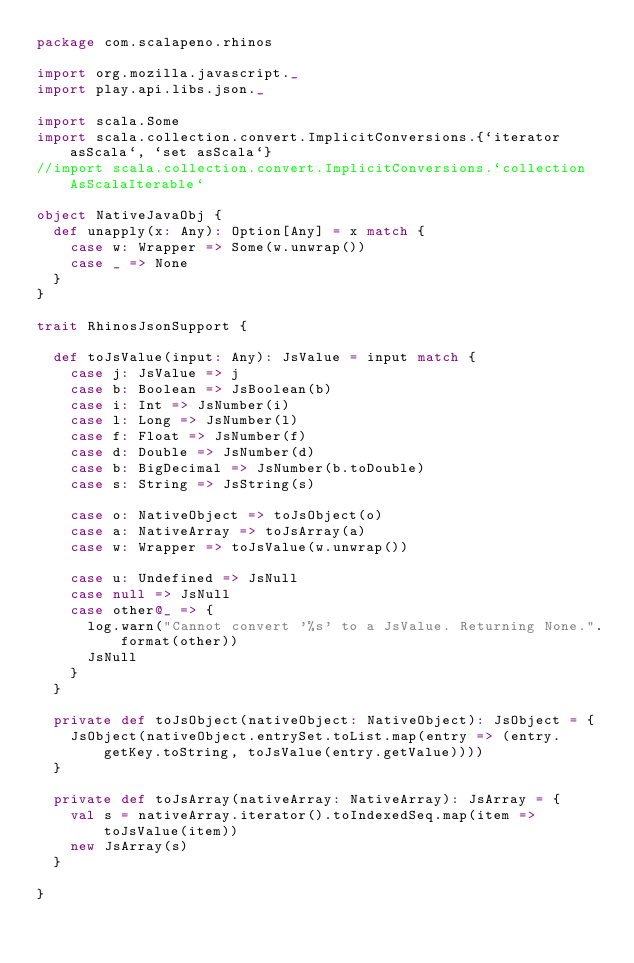Convert code to text. <code><loc_0><loc_0><loc_500><loc_500><_Scala_>package com.scalapeno.rhinos

import org.mozilla.javascript._
import play.api.libs.json._

import scala.Some
import scala.collection.convert.ImplicitConversions.{`iterator asScala`, `set asScala`}
//import scala.collection.convert.ImplicitConversions.`collection AsScalaIterable`

object NativeJavaObj {
  def unapply(x: Any): Option[Any] = x match {
    case w: Wrapper => Some(w.unwrap())
    case _ => None
  }
}

trait RhinosJsonSupport {

  def toJsValue(input: Any): JsValue = input match {
    case j: JsValue => j
    case b: Boolean => JsBoolean(b)
    case i: Int => JsNumber(i)
    case l: Long => JsNumber(l)
    case f: Float => JsNumber(f)
    case d: Double => JsNumber(d)
    case b: BigDecimal => JsNumber(b.toDouble)
    case s: String => JsString(s)

    case o: NativeObject => toJsObject(o)
    case a: NativeArray => toJsArray(a)
    case w: Wrapper => toJsValue(w.unwrap())

    case u: Undefined => JsNull
    case null => JsNull
    case other@_ => {
      log.warn("Cannot convert '%s' to a JsValue. Returning None.".format(other))
      JsNull
    }
  }

  private def toJsObject(nativeObject: NativeObject): JsObject = {
    JsObject(nativeObject.entrySet.toList.map(entry => (entry.getKey.toString, toJsValue(entry.getValue))))
  }

  private def toJsArray(nativeArray: NativeArray): JsArray = {
    val s = nativeArray.iterator().toIndexedSeq.map(item => toJsValue(item))
    new JsArray(s)
  }

}</code> 